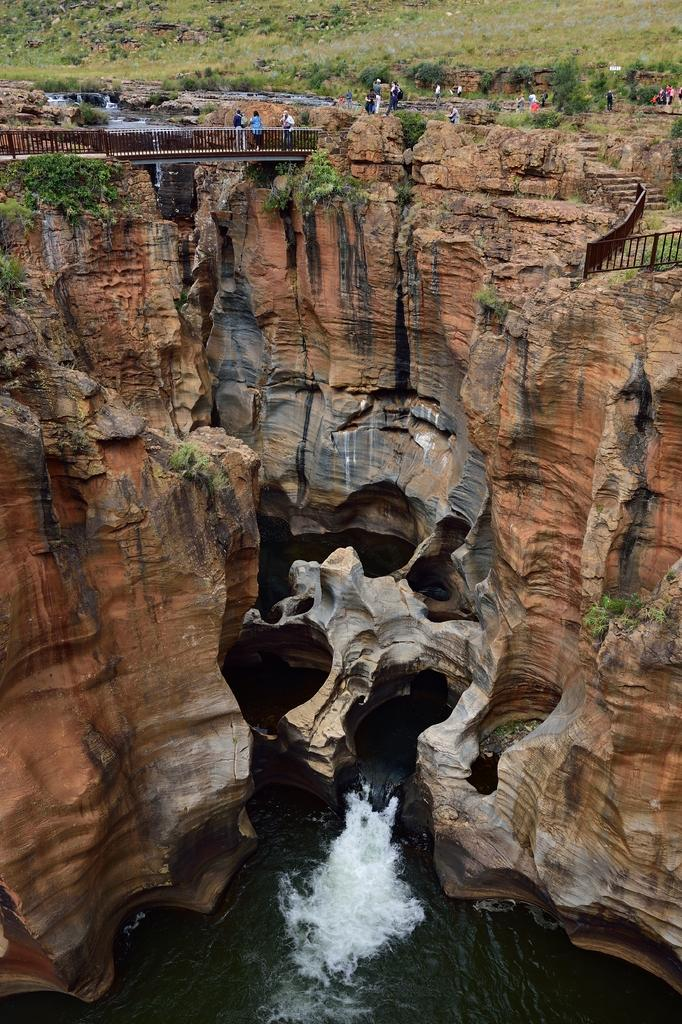What natural element can be seen in the image? Water is visible in the image. What type of geological formation is present in the image? There are rocks in the image. What type of vegetation is present in the image? There are plants in the image. What type of man-made structure is present in the image? There is a bridge in the image. What type of ground cover is present in the image? There is grass visible in the image. What type of barrier is present in the image? There are fences in the image. Can you tell me how many uncles are in the image? There is no mention of an uncle in the image. What type of clothing is the girl wearing in the image? There is no mention of a girl in the image. 